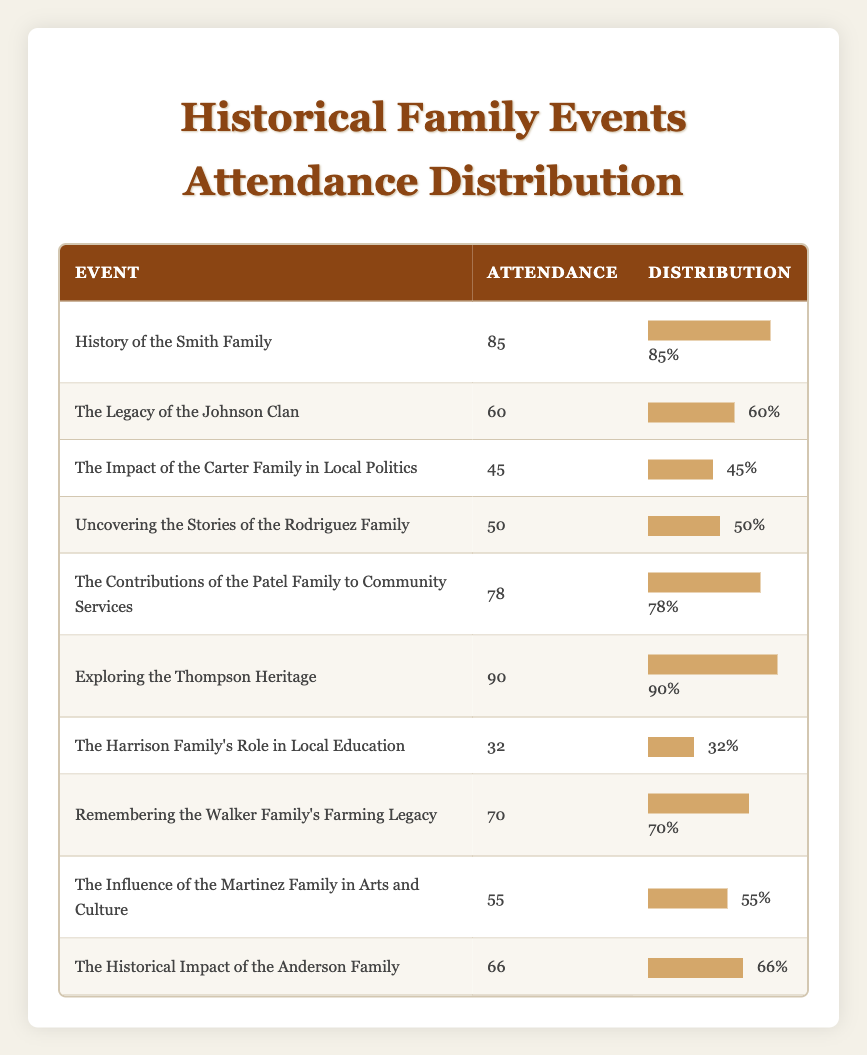What is the attendance for the event "Exploring the Thompson Heritage"? By locating the event in the table, we can find its corresponding attendance number directly, which is listed as 90.
Answer: 90 Which event had the lowest attendance? To determine the event with the lowest attendance, we look through the attendance values and identify the minimum, which in this case is 32 for "The Harrison Family's Role in Local Education."
Answer: 32 What is the average attendance for all events? We sum the attendance numbers (85 + 60 + 45 + 50 + 78 + 90 + 32 + 70 + 55 + 66 =  785) and divide by the number of events (10). Thus, the average attendance is 785/10 = 78.5.
Answer: 78.5 Are there more events with attendance above 70 than below 50? By examining the table, we see that three events had attendance above 70 (85, 78, and 90) and three events had attendance below 50 (45 and 32). Since there are equal numbers of events in both categories, the answer is no.
Answer: No What is the difference in attendance between the highest and the lowest attended events? The highest attendance is 90 for "Exploring the Thompson Heritage," and the lowest is 32 for "The Harrison Family's Role in Local Education." The difference is calculated as 90 - 32 = 58.
Answer: 58 Which family had events that had an attendance of at least 60? In examining the table, we find that the events with attendance at least 60 include "History of the Smith Family" (85), "The Legacy of the Johnson Clan" (60), "The Contributions of the Patel Family to Community Services" (78), "Exploring the Thompson Heritage" (90), "Remembering the Walker Family's Farming Legacy" (70), "The Historical Impact of the Anderson Family" (66), and "The Influence of the Martinez Family in Arts and Culture" (55), so, the families with events meeting this criteria are Smith, Johnson, Patel, Thompson, Walker, Anderson, and Martinez.
Answer: Smith, Johnson, Patel, Thompson, Walker, Anderson How many events had attendance between 50 and 80? To find this, we count the events which have attendance numbers falling between 50 and 80: "Uncovering the Stories of the Rodriguez Family" (50), "The Contributions of the Patel Family to Community Services" (78), "Remembering the Walker Family's Farming Legacy" (70), and "The Historical Impact of the Anderson Family" (66) which totals to 4 events.
Answer: 4 Is there an event with exactly 60 attendees? By checking the attendance numbers in the table, we see that "The Legacy of the Johnson Clan" has exactly 60 attendees.
Answer: Yes What percentage of attendees were present at events featuring the Carter, Rodriguez, and Harrison Families combined? The total attendance for these events is 45 (Carter) + 50 (Rodriguez) + 32 (Harrison) = 127. The total attendance for all events is 785, so the percentage is (127/785) * 100 ≈ 16.2%.
Answer: 16.2% 